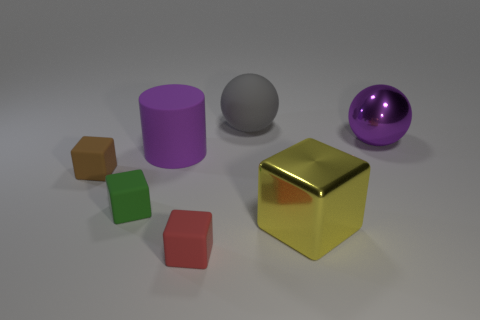Is the yellow object made of the same material as the tiny red object?
Offer a very short reply. No. There is a rubber block that is in front of the large block; is it the same size as the shiny thing that is in front of the tiny brown rubber thing?
Your answer should be compact. No. Is the number of gray rubber objects less than the number of tiny blue spheres?
Give a very brief answer. No. What number of rubber objects are either brown blocks or cylinders?
Offer a terse response. 2. Is there a green rubber block to the right of the big matte object that is right of the big purple cylinder?
Your answer should be compact. No. Is the big ball that is behind the large shiny sphere made of the same material as the green object?
Keep it short and to the point. Yes. How many other things are the same color as the rubber sphere?
Your response must be concise. 0. Do the cylinder and the big rubber sphere have the same color?
Keep it short and to the point. No. There is a metallic thing that is behind the tiny matte cube to the left of the small green rubber object; what is its size?
Your response must be concise. Large. Are the tiny object in front of the yellow shiny block and the big purple thing that is to the right of the large purple matte thing made of the same material?
Ensure brevity in your answer.  No. 